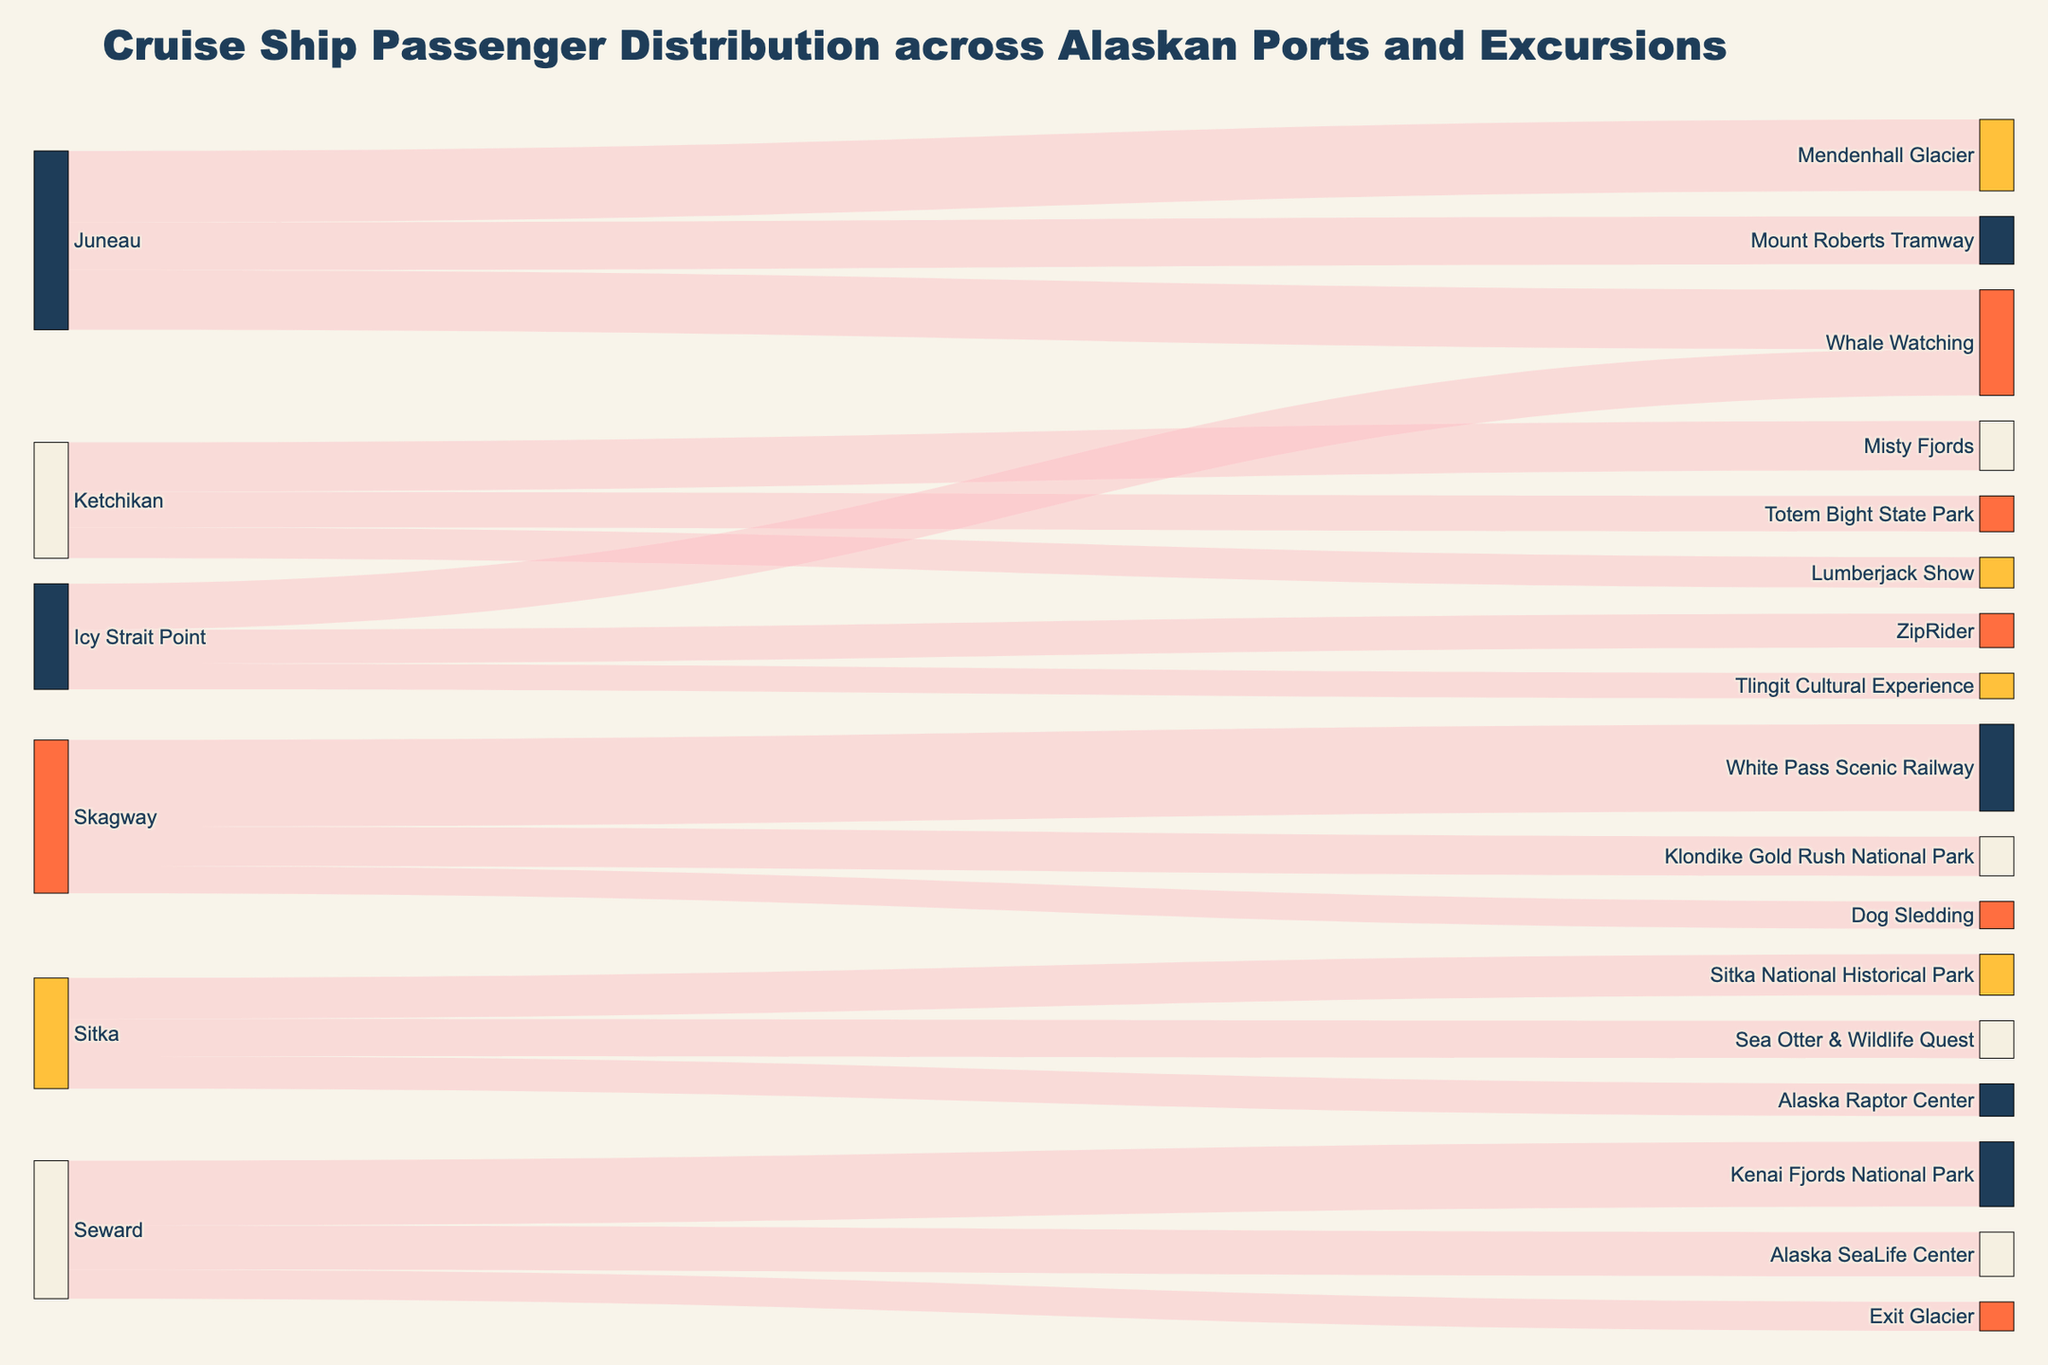How many excursions does Juneau offer? The diagram shows Juneau connecting to several excursions. Count the number of unique excursions. Juneau connects to Whale Watching, Mendenhall Glacier, and Mount Roberts Tramway.
Answer: 3 Which excursion in Skagway has the highest number of passengers? Look at the connections from Skagway and compare the number of passengers each excursion receives. The excursions connected to Skagway are White Pass Scenic Railway, Klondike Gold Rush National Park, and Dog Sledding. White Pass Scenic Railway has the highest number at 5100 passengers.
Answer: White Pass Scenic Railway How many total passengers visit Skagway? Sum the values of passengers visiting the three Skagway excursions: 5100 (White Pass Scenic Railway) + 2300 (Klondike Gold Rush National Park) + 1600 (Dog Sledding).
Answer: 9000 Which port offers the fewest excursions? Count the number of excursions each port offers by tracing the connections originating from each port. Icy Strait Point offers three excursions, which is the fewest when compared to other ports.
Answer: Icy Strait Point Compare the number of passengers for Whale Watching between Juneau and Icy Strait Point. Which has more? Identify the number of passengers going to Whale Watching from both ports: Juneau has 3500 and Icy Strait Point has 2700. Compare these numbers.
Answer: Juneau Which three excursions have the smallest number of passengers? Look at the values for each excursion and identify the three smallest values. The smallest numbers of passengers are for Tlingit Cultural Experience (1500), Dog Sledding (1600), and Exit Glacier (1700).
Answer: Tlingit Cultural Experience, Dog Sledding, Exit Glacier What is the main color theme of the labels in the diagram? Examine the colors used for the labels in the figure. They are mainly shades of blue, cream, orange, and yellow.
Answer: Blue, cream, orange, yellow How many ports are depicted in the figure? Count the unique sources which represent ports. Juneau, Ketchikan, Skagway, Sitka, Icy Strait Point, and Seward are present.
Answer: 6 If we sum all passengers visiting excursions from Juneau, how many are there? Add up the number of passengers for the three excursions originating from Juneau: 3500 (Whale Watching) + 4200 (Mendenhall Glacier) + 2800 (Mount Roberts Tramway).
Answer: 10500 Does Sitka have more passengers visiting Alaska Raptor Center or Sea Otter & Wildlife Quest? Compare the number of passengers visiting these two excursions from Sitka. Alaska Raptor Center has 1900 passengers, whereas Sea Otter & Wildlife Quest has 2200 passengers.
Answer: Sea Otter & Wildlife Quest 